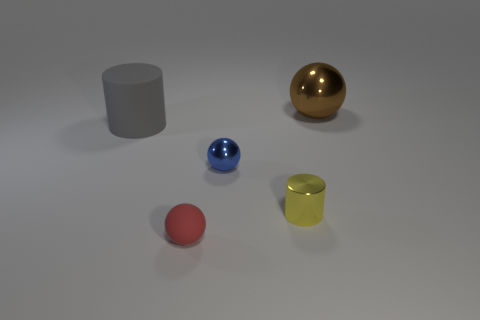What size is the brown sphere that is the same material as the blue thing?
Provide a succinct answer. Large. How many gray things are either large shiny balls or large cylinders?
Your response must be concise. 1. There is a rubber thing behind the small yellow shiny object; what number of tiny spheres are behind it?
Provide a succinct answer. 0. Is the number of things that are in front of the large metallic thing greater than the number of small metallic cylinders to the left of the small cylinder?
Offer a very short reply. Yes. What material is the big gray object?
Your answer should be very brief. Rubber. Are there any blue things that have the same size as the red rubber ball?
Provide a succinct answer. Yes. There is another object that is the same size as the gray thing; what is it made of?
Offer a very short reply. Metal. How many big gray things are there?
Offer a terse response. 1. There is a rubber object in front of the small yellow cylinder; what size is it?
Ensure brevity in your answer.  Small. Is the number of large metallic spheres in front of the tiny cylinder the same as the number of purple shiny cylinders?
Offer a very short reply. Yes. 